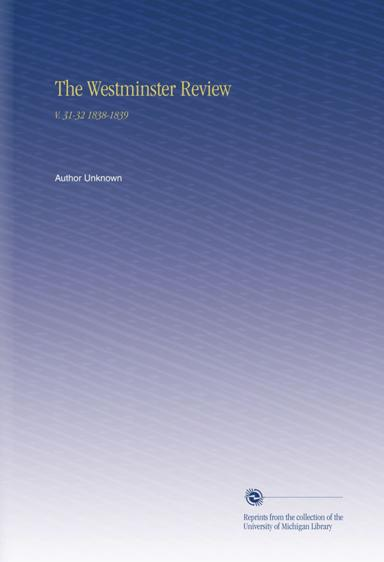What is the topic of the text mentioned in the image? The topic of the text is "The Westminster Review V.31 32 1838 1839." What is the source of the reprints? The reprints are from the collection of the University of Michigan Library. 